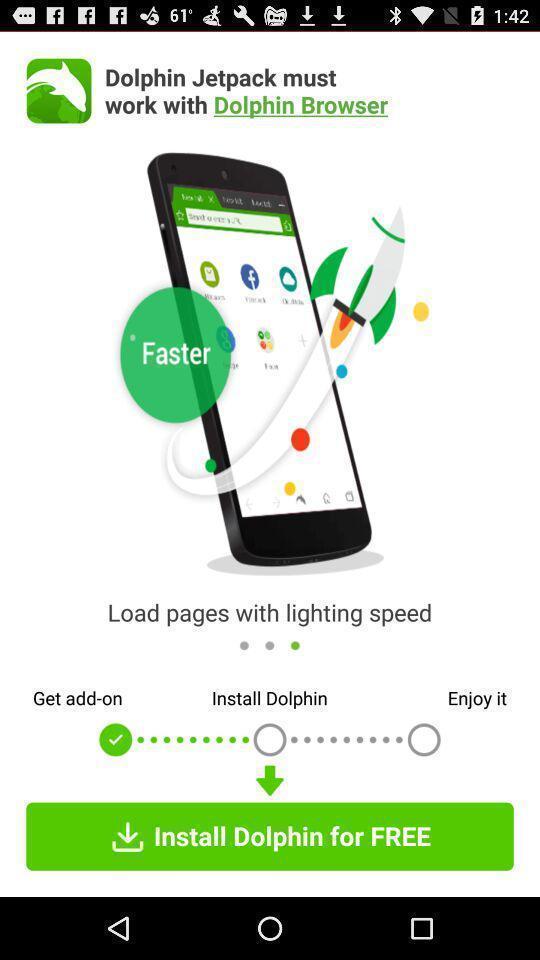Tell me about the visual elements in this screen capture. Page showing initial step on app. 